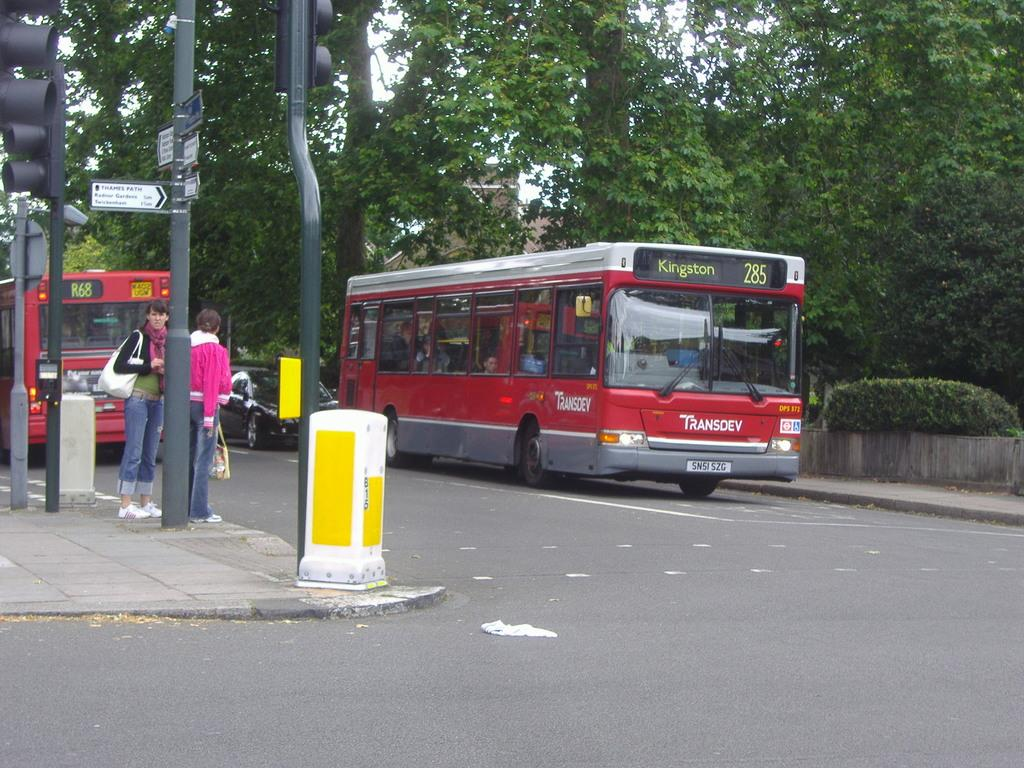What type of vehicles can be seen on the road in the image? There are two red color buses on the road in the image. How many people are standing in the image? There are two persons standing in the image. What type of natural elements are present in the image? Plants and trees are visible in the image. What type of signage is present in the image? Direction boards are present in the image. What type of traffic control devices are present in the image? Signal lights are attached to poles in the image. What type of structure is present in the image? There is at least one building in the image. What part of the natural environment is visible in the image? The sky is visible in the image. What type of tramp can be seen jumping in the image? There is no tramp present in the image. What type of spring is used to support the buses in the image? There is no mention of springs or any specific support system for the buses in the image. 